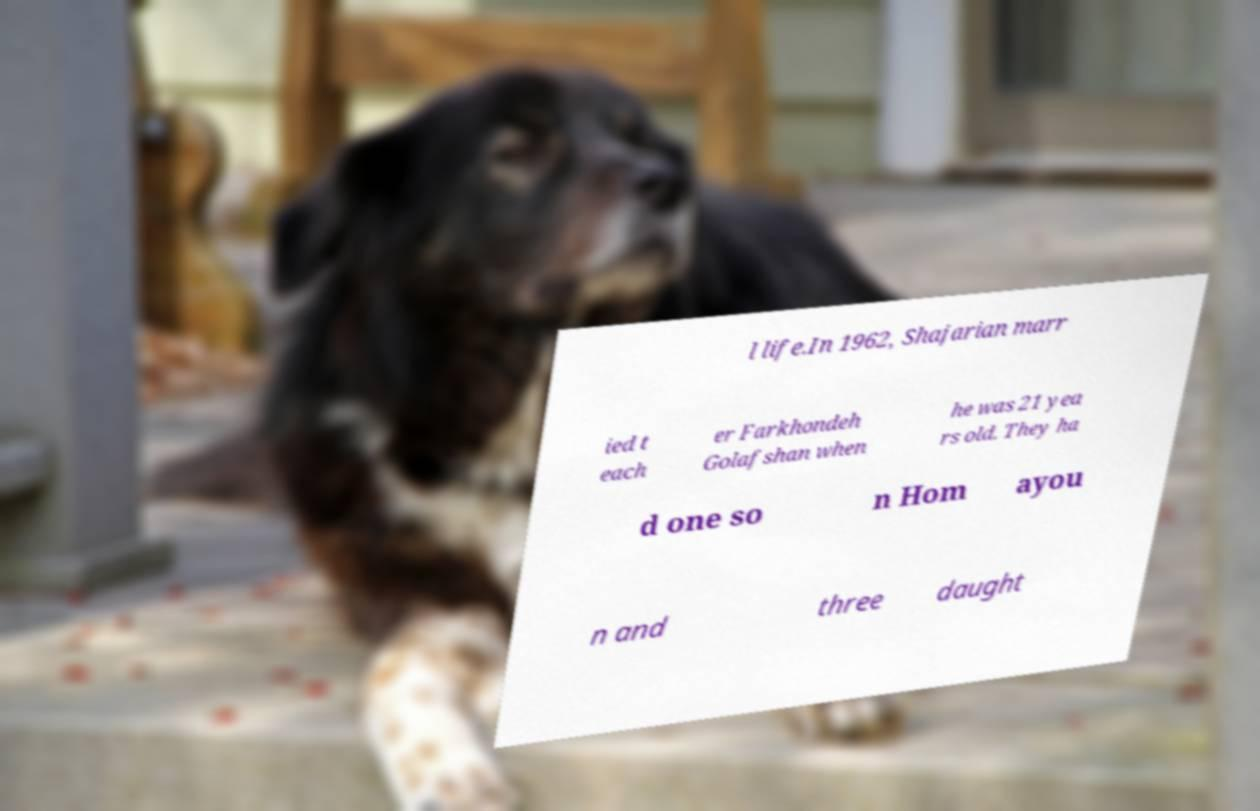Please read and relay the text visible in this image. What does it say? l life.In 1962, Shajarian marr ied t each er Farkhondeh Golafshan when he was 21 yea rs old. They ha d one so n Hom ayou n and three daught 